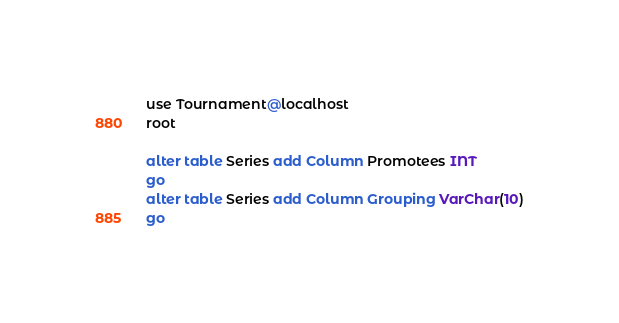<code> <loc_0><loc_0><loc_500><loc_500><_SQL_>use Tournament@localhost
root

alter table Series add Column Promotees INT
go
alter table Series add Column Grouping VarChar(10)
go
</code> 